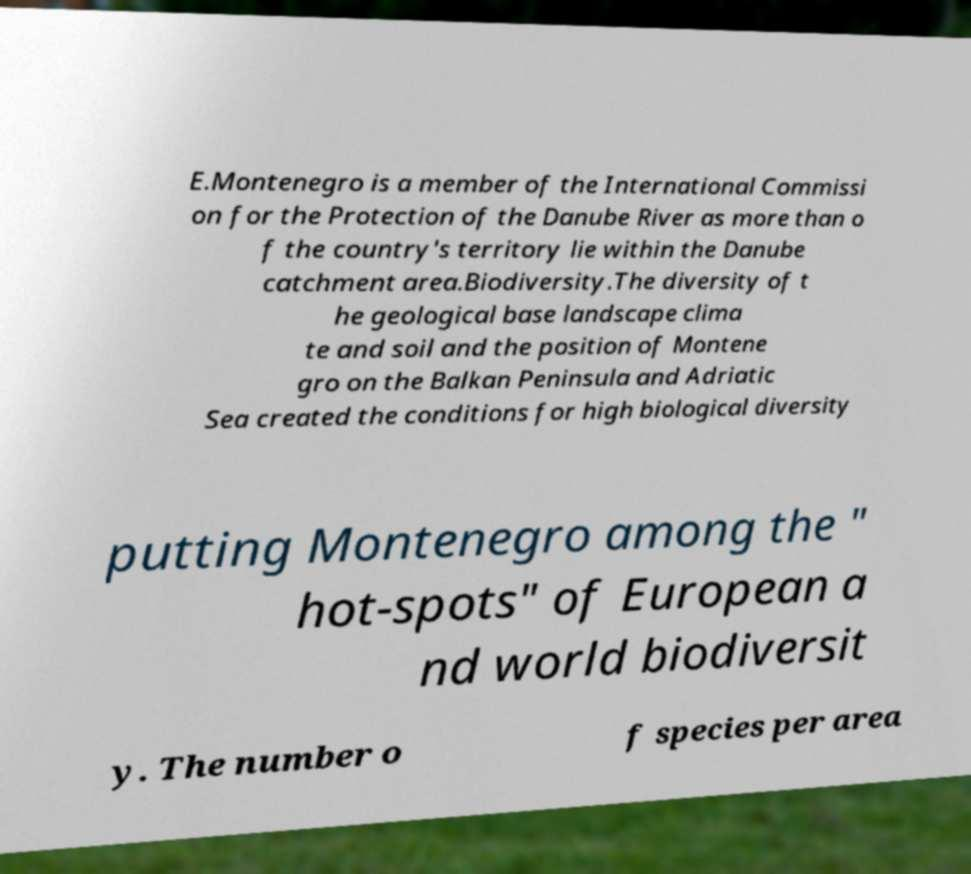Please identify and transcribe the text found in this image. E.Montenegro is a member of the International Commissi on for the Protection of the Danube River as more than o f the country's territory lie within the Danube catchment area.Biodiversity.The diversity of t he geological base landscape clima te and soil and the position of Montene gro on the Balkan Peninsula and Adriatic Sea created the conditions for high biological diversity putting Montenegro among the " hot-spots" of European a nd world biodiversit y. The number o f species per area 